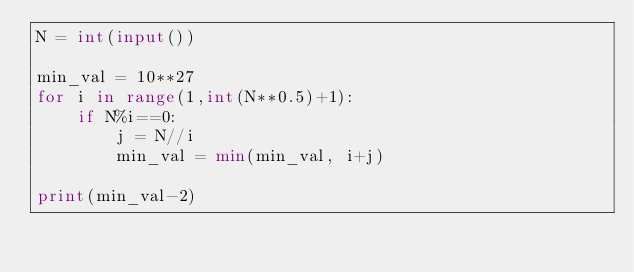Convert code to text. <code><loc_0><loc_0><loc_500><loc_500><_Python_>N = int(input())

min_val = 10**27
for i in range(1,int(N**0.5)+1):
    if N%i==0:
        j = N//i
        min_val = min(min_val, i+j)

print(min_val-2)
</code> 